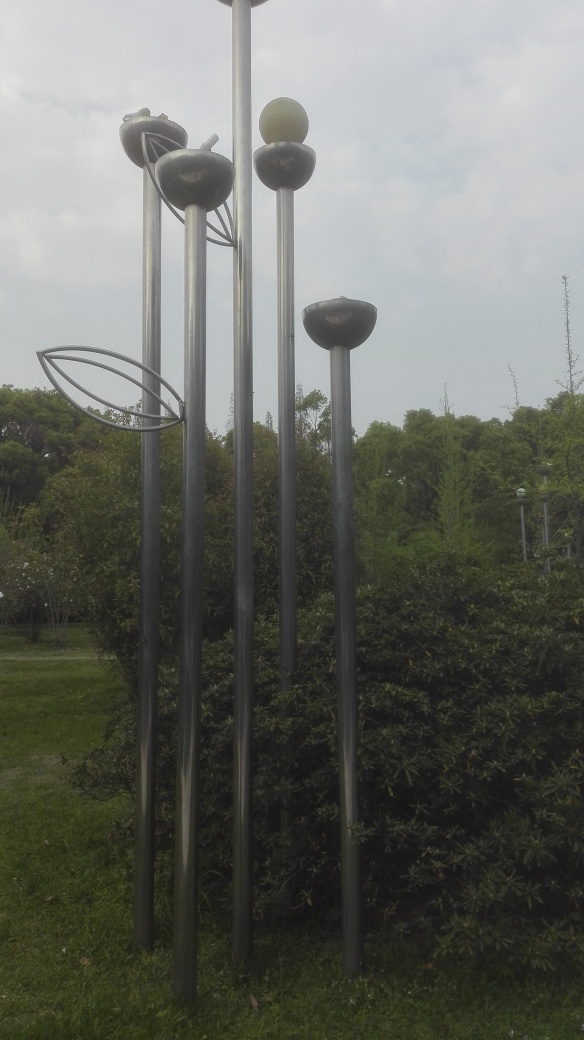Where might this photo have been taken? Given the artistic nature of the sculptures and the garden setting, it is likely that this photo was taken in a public art space or an outdoor area of an art museum. What time of day does the lighting suggest? The soft shadows and diffused light suggest that this photo was taken on an overcast day or possibly in the early morning or late afternoon when the sunlight is not as harsh. 